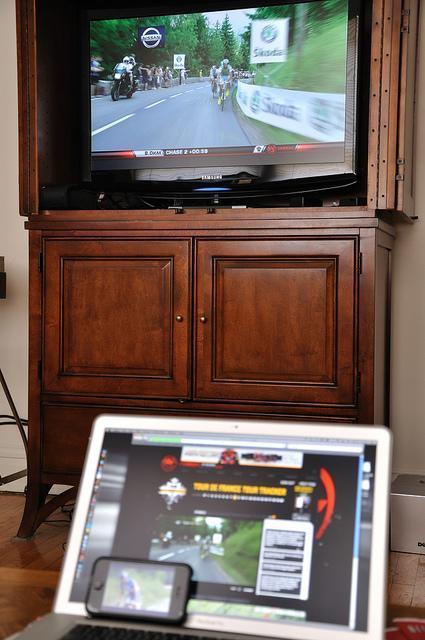Verify the accuracy of this image caption: "The tv is above the bicycle.".
Answer yes or no. No. 